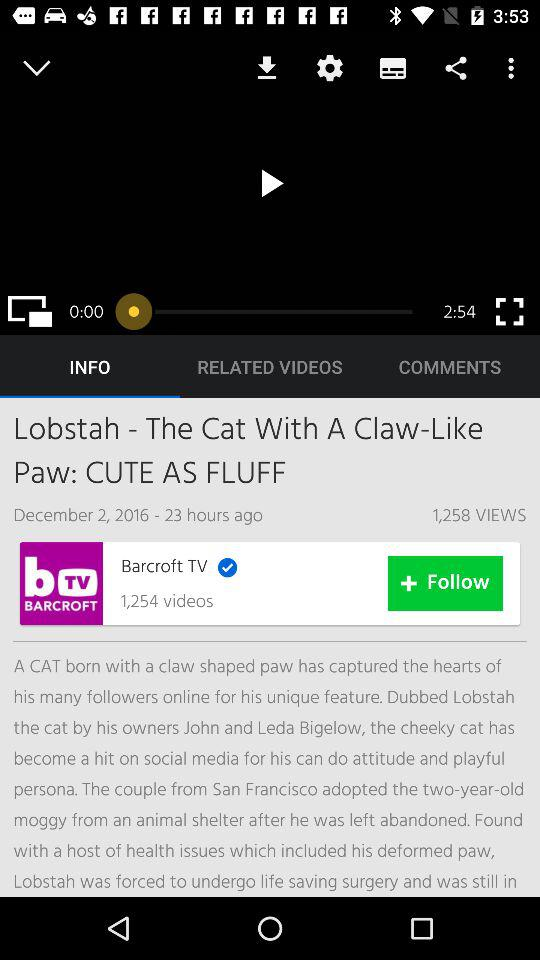What news was published on December 2, 2016? The news that was published on December 2, 2016 was "Lobstah - The Cat With A Claw-Like Paw: CUTE AS FLUFF". 